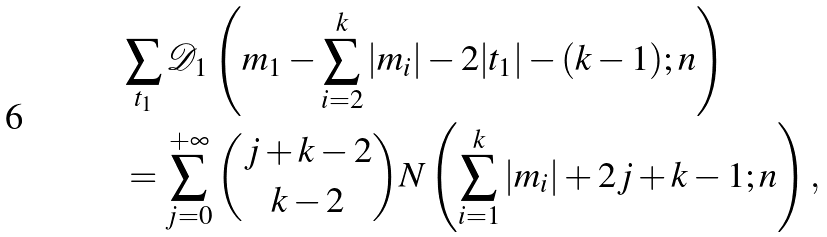<formula> <loc_0><loc_0><loc_500><loc_500>& \sum _ { t _ { 1 } } \mathcal { D } _ { 1 } \left ( m _ { 1 } - \sum _ { i = 2 } ^ { k } | m _ { i } | - 2 | t _ { 1 } | - ( k - 1 ) ; n \right ) \\ & = \sum _ { j = 0 } ^ { + \infty } { j + k - 2 \choose k - 2 } N \left ( \sum _ { i = 1 } ^ { k } | m _ { i } | + 2 j + k - 1 ; n \right ) ,</formula> 